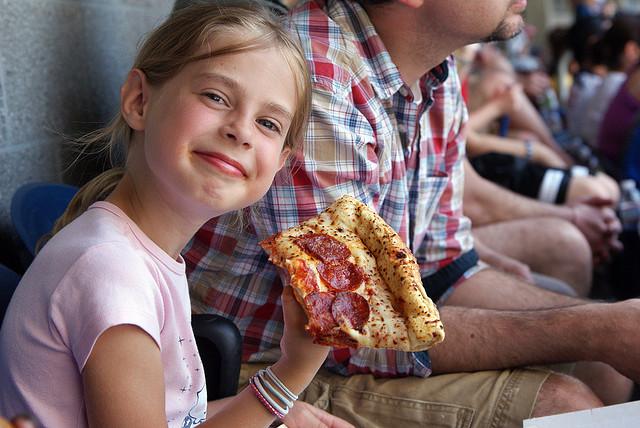What is the girl eating?
Concise answer only. Pizza. What topping is on the pizza?
Quick response, please. Pepperoni. Does the pizza have a thick crust?
Short answer required. Yes. 